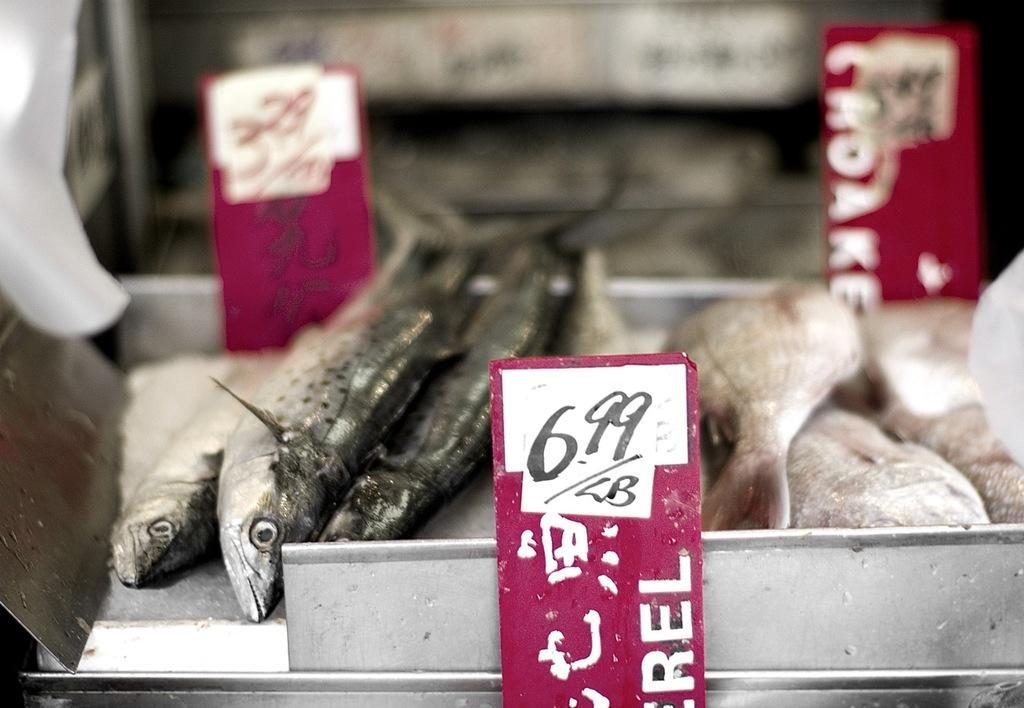Describe this image in one or two sentences. This picture seems to be clicked inside. In the center we can see a tray containing fishes and some other food items and we can see the small boards on which we can see the text and numbers. The background of the image is blurry and we can see there are some objects in the background. 